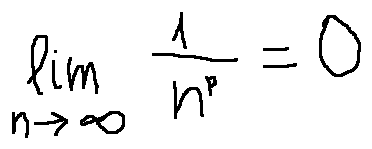<formula> <loc_0><loc_0><loc_500><loc_500>\lim \lim i t s _ { n \rightarrow \infty } \frac { 1 } { n ^ { p } } = 0</formula> 